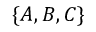<formula> <loc_0><loc_0><loc_500><loc_500>\{ A , B , C \}</formula> 